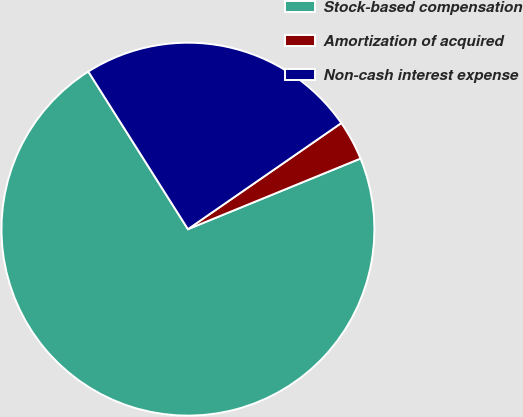<chart> <loc_0><loc_0><loc_500><loc_500><pie_chart><fcel>Stock-based compensation<fcel>Amortization of acquired<fcel>Non-cash interest expense<nl><fcel>72.21%<fcel>3.45%<fcel>24.34%<nl></chart> 